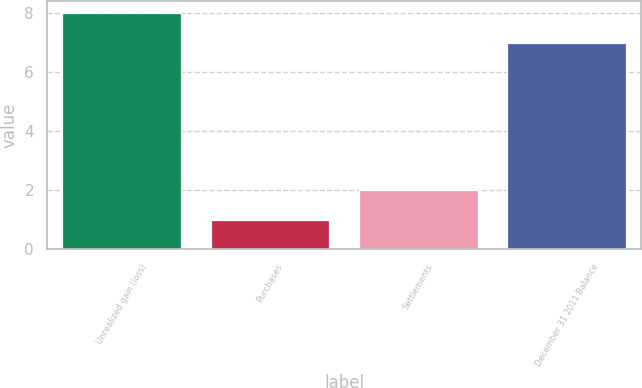<chart> <loc_0><loc_0><loc_500><loc_500><bar_chart><fcel>Unrealized gain (loss)<fcel>Purchases<fcel>Settlements<fcel>December 31 2011 Balance<nl><fcel>8<fcel>1<fcel>2<fcel>7<nl></chart> 